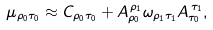Convert formula to latex. <formula><loc_0><loc_0><loc_500><loc_500>\mu _ { \rho _ { 0 } \tau _ { 0 } } \approx C _ { \rho _ { 0 } \tau _ { 0 } } + A _ { \rho _ { 0 } } ^ { \, \rho _ { 1 } } \omega _ { \rho _ { 1 } \tau _ { 1 } } A _ { \tau _ { 0 } } ^ { \, \tau _ { 1 } } ,</formula> 